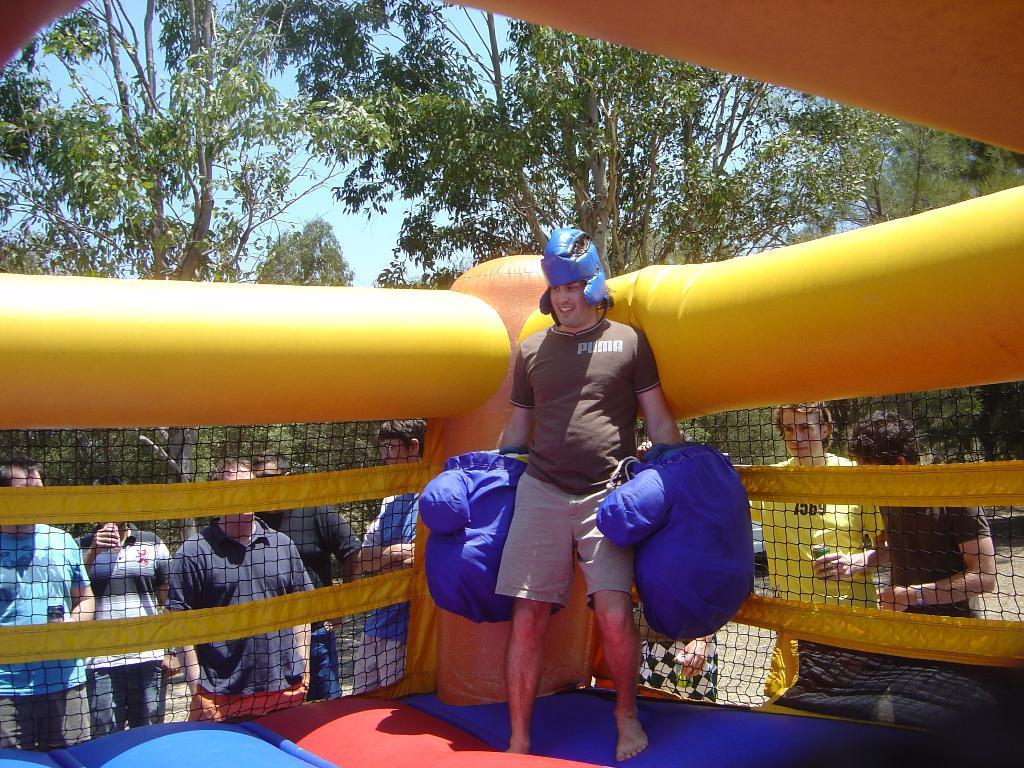Could you give a brief overview of what you see in this image? This is an outside view. Here I can see an inflatable boxing ring. One man is wearing gloves, helmet and standing on it. Behind this few men are standing. In the background there are many trees and also I can see the sky. 